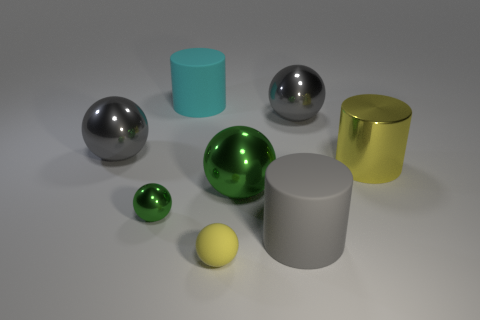How many objects are left of the rubber ball and behind the yellow metal object?
Your response must be concise. 2. How many objects are big gray metal spheres or large gray balls on the right side of the large cyan thing?
Make the answer very short. 2. The thing that is the same color as the small rubber ball is what shape?
Provide a short and direct response. Cylinder. What is the color of the big metal thing in front of the big yellow metal cylinder?
Provide a succinct answer. Green. How many things are things that are behind the tiny rubber ball or gray rubber cylinders?
Your response must be concise. 7. What is the color of the shiny cylinder that is the same size as the cyan rubber cylinder?
Provide a short and direct response. Yellow. Is the number of big shiny cylinders that are behind the cyan matte thing greater than the number of matte cylinders?
Ensure brevity in your answer.  No. There is a thing that is both right of the cyan cylinder and behind the big yellow object; what material is it?
Your answer should be compact. Metal. There is a big metallic sphere that is in front of the yellow metallic thing; is it the same color as the big matte cylinder in front of the yellow cylinder?
Your response must be concise. No. What number of other objects are there of the same size as the cyan rubber object?
Your answer should be compact. 5. 